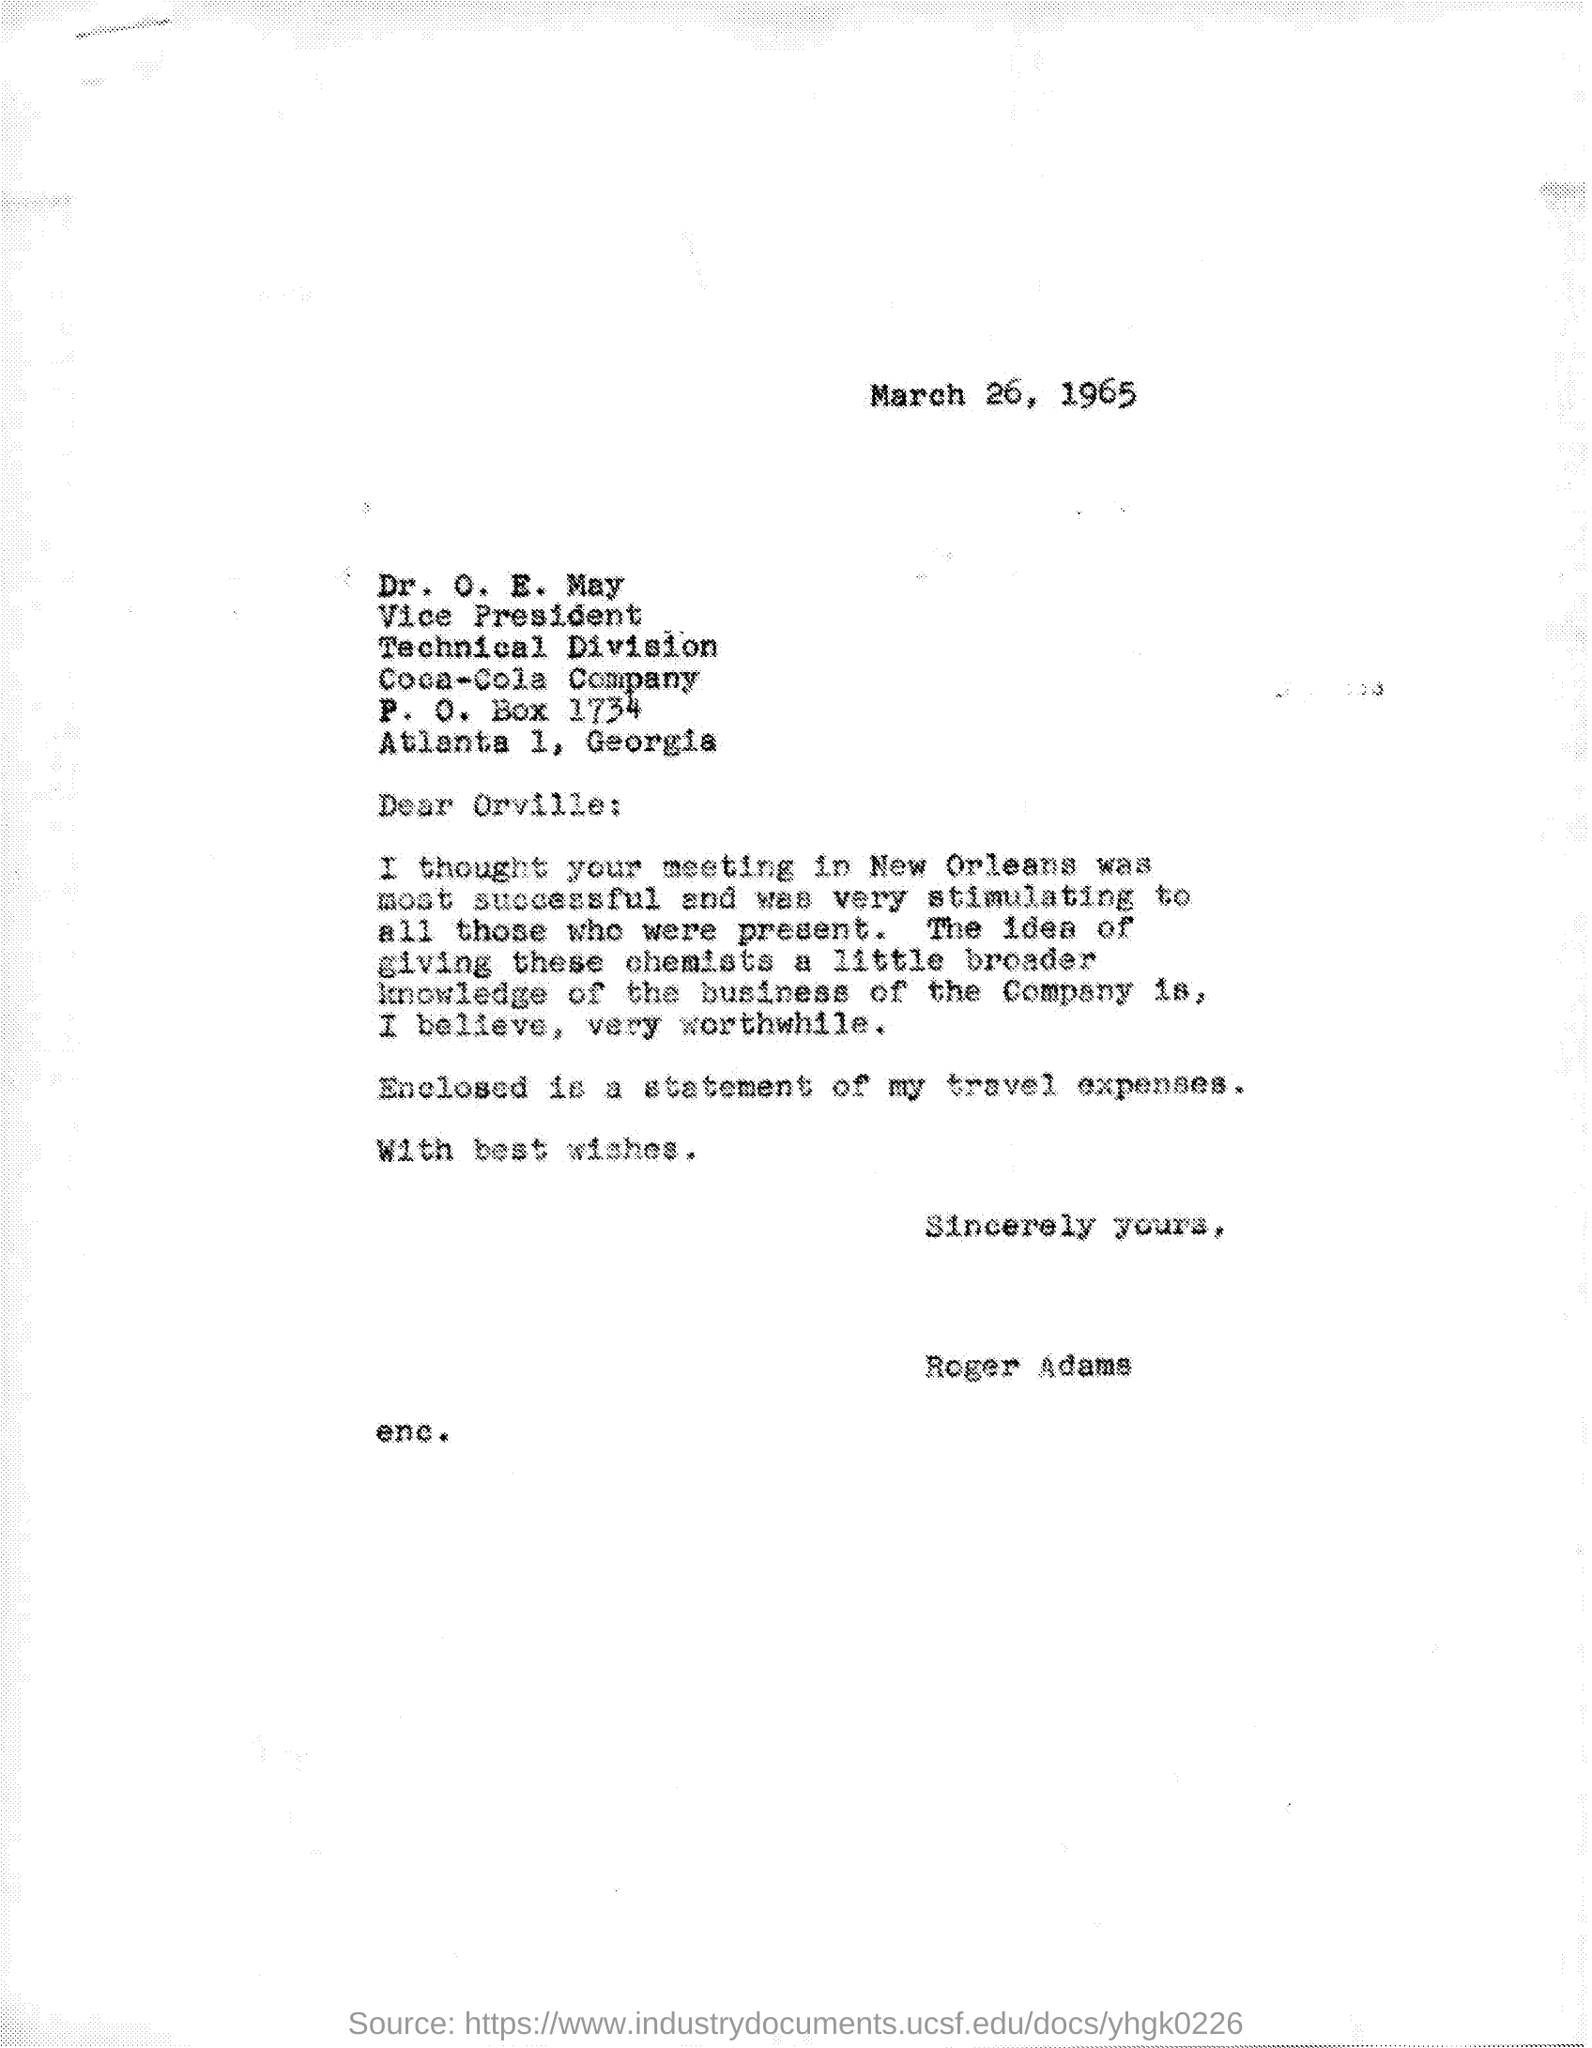What is the designation of dr. o.e. may ?
Ensure brevity in your answer.  Vice president. To whom this letter was written ?
Keep it short and to the point. Dr. O. E. May. What is the name of the division mentioned in the given letter ?
Your answer should be very brief. Technical division. What is the p.o.box number mentioned in the given page ?
Provide a succinct answer. 1734. 